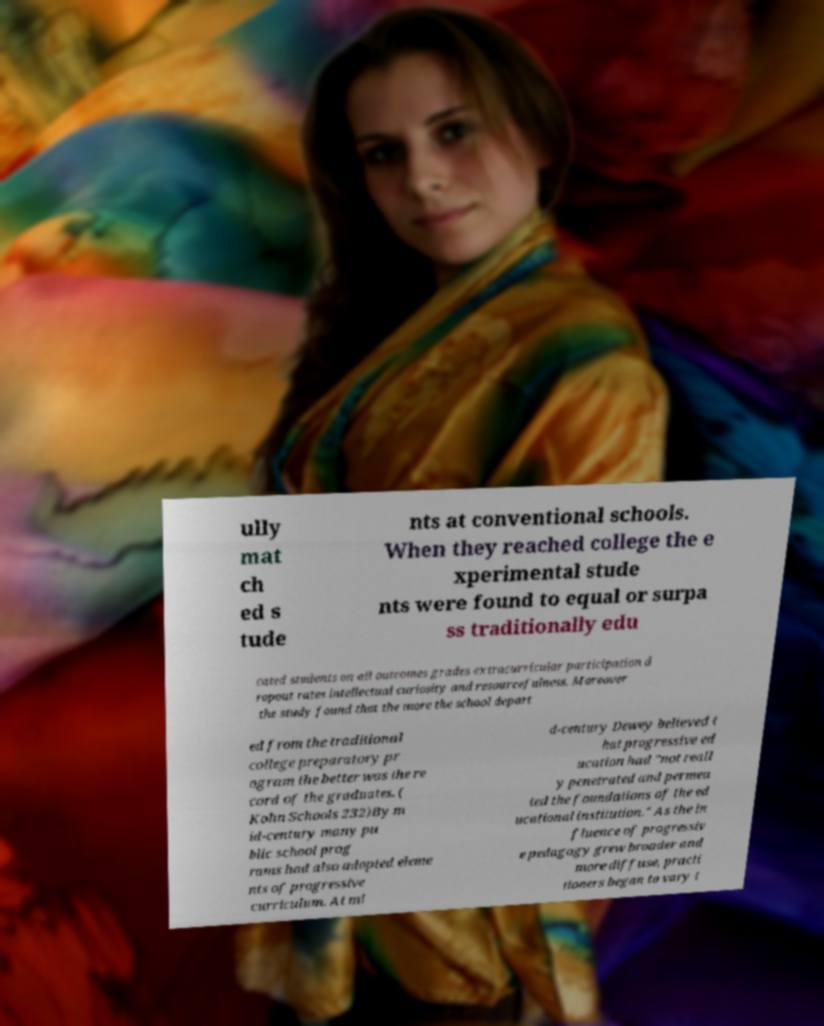Could you assist in decoding the text presented in this image and type it out clearly? ully mat ch ed s tude nts at conventional schools. When they reached college the e xperimental stude nts were found to equal or surpa ss traditionally edu cated students on all outcomes grades extracurricular participation d ropout rates intellectual curiosity and resourcefulness. Moreover the study found that the more the school depart ed from the traditional college preparatory pr ogram the better was the re cord of the graduates. ( Kohn Schools 232)By m id-century many pu blic school prog rams had also adopted eleme nts of progressive curriculum. At mi d-century Dewey believed t hat progressive ed ucation had "not reall y penetrated and permea ted the foundations of the ed ucational institution." As the in fluence of progressiv e pedagogy grew broader and more diffuse, practi tioners began to vary t 